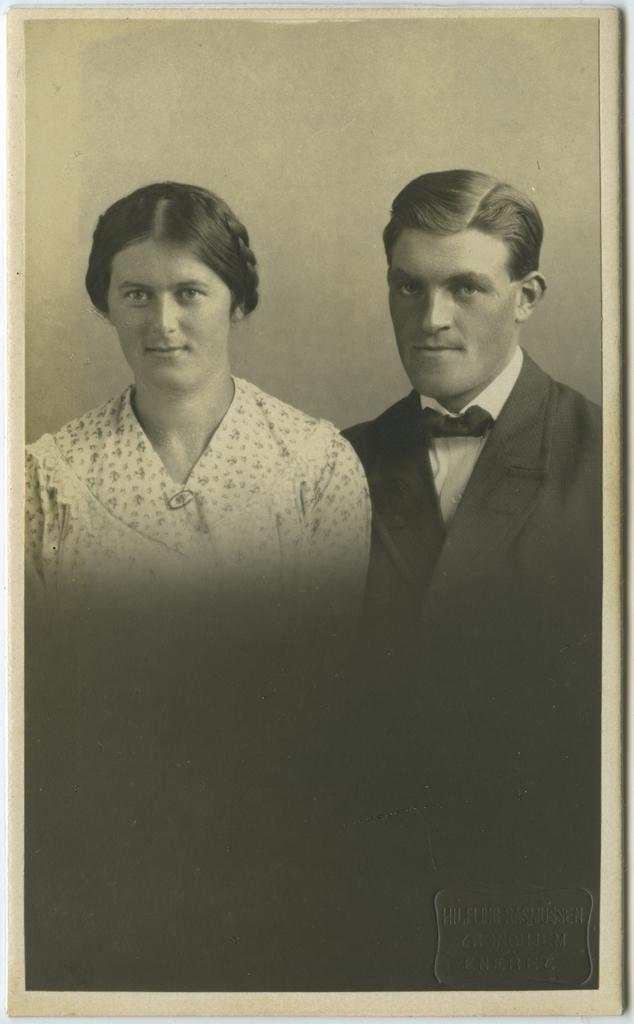Who are the people in the image? There is a man and a woman in the image. Where are the man and woman located in the image? The man and woman are in the center of the image. What type of egg is the woman holding in the image? There is no egg present in the image; the woman is not holding anything. 